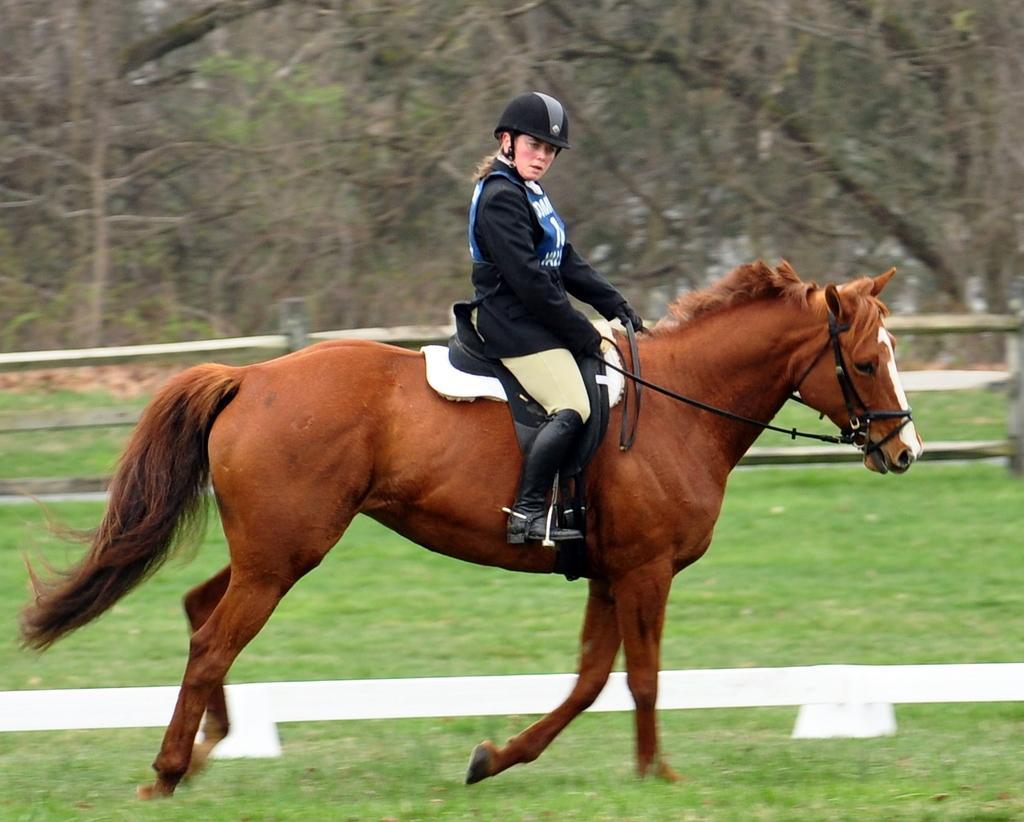Describe this image in one or two sentences. In this picture I can observe a person riding a horse. The horse is in brown color. I can observe a railing in this picture. In the background there are trees. 